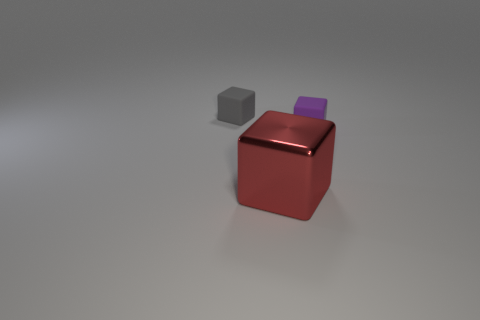Add 1 tiny blue metal cubes. How many objects exist? 4 Subtract all brown spheres. Subtract all tiny rubber blocks. How many objects are left? 1 Add 1 rubber cubes. How many rubber cubes are left? 3 Add 3 big yellow metal cylinders. How many big yellow metal cylinders exist? 3 Subtract 0 yellow cylinders. How many objects are left? 3 